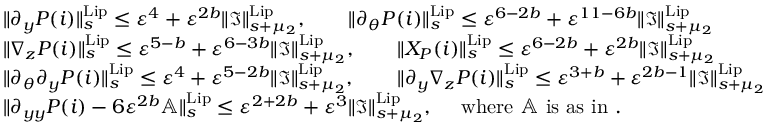<formula> <loc_0><loc_0><loc_500><loc_500>\begin{array} { r l } & { \| \partial _ { y } P ( i ) \| _ { s } ^ { L i p } \leq \varepsilon ^ { 4 } + \varepsilon ^ { 2 b } \| \mathfrak { I } \| _ { s + \mu _ { 2 } } ^ { L i p } , \quad \| \partial _ { \theta } P ( i ) \| _ { s } ^ { L i p } \leq \varepsilon ^ { 6 - 2 b } + \varepsilon ^ { 1 1 - 6 b } \| \mathfrak { I } \| _ { s + \mu _ { 2 } } ^ { L i p } } \\ & { \| \nabla _ { z } P ( i ) \| _ { s } ^ { L i p } \leq \varepsilon ^ { 5 - b } + \varepsilon ^ { 6 - 3 b } \| \mathfrak { I } \| _ { s + \mu _ { 2 } } ^ { L i p } , \quad \| X _ { P } ( i ) \| _ { s } ^ { L i p } \leq \varepsilon ^ { 6 - 2 b } + \varepsilon ^ { 2 b } \| \mathfrak { I } \| _ { s + \mu _ { 2 } } ^ { L i p } } \\ & { \| \partial _ { \theta } \partial _ { y } P ( i ) \| _ { s } ^ { L i p } \leq \varepsilon ^ { 4 } + \varepsilon ^ { 5 - 2 b } \| \mathfrak { I } \| _ { s + \mu _ { 2 } } ^ { L i p } , \quad \| \partial _ { y } \nabla _ { z } P ( i ) \| _ { s } ^ { L i p } \leq \varepsilon ^ { 3 + b } + \varepsilon ^ { 2 b - 1 } \| \mathfrak { I } \| _ { s + \mu _ { 2 } } ^ { L i p } } \\ & { \| \partial _ { y y } P ( i ) - 6 \varepsilon ^ { 2 b } \mathbb { A } \| _ { s } ^ { L i p } \leq \varepsilon ^ { 2 + 2 b } + \varepsilon ^ { 3 } \| \mathfrak { I } \| _ { s + \mu _ { 2 } } ^ { L i p } , \quad w h e r e \mathbb { A } i s a s i n . } \end{array}</formula> 